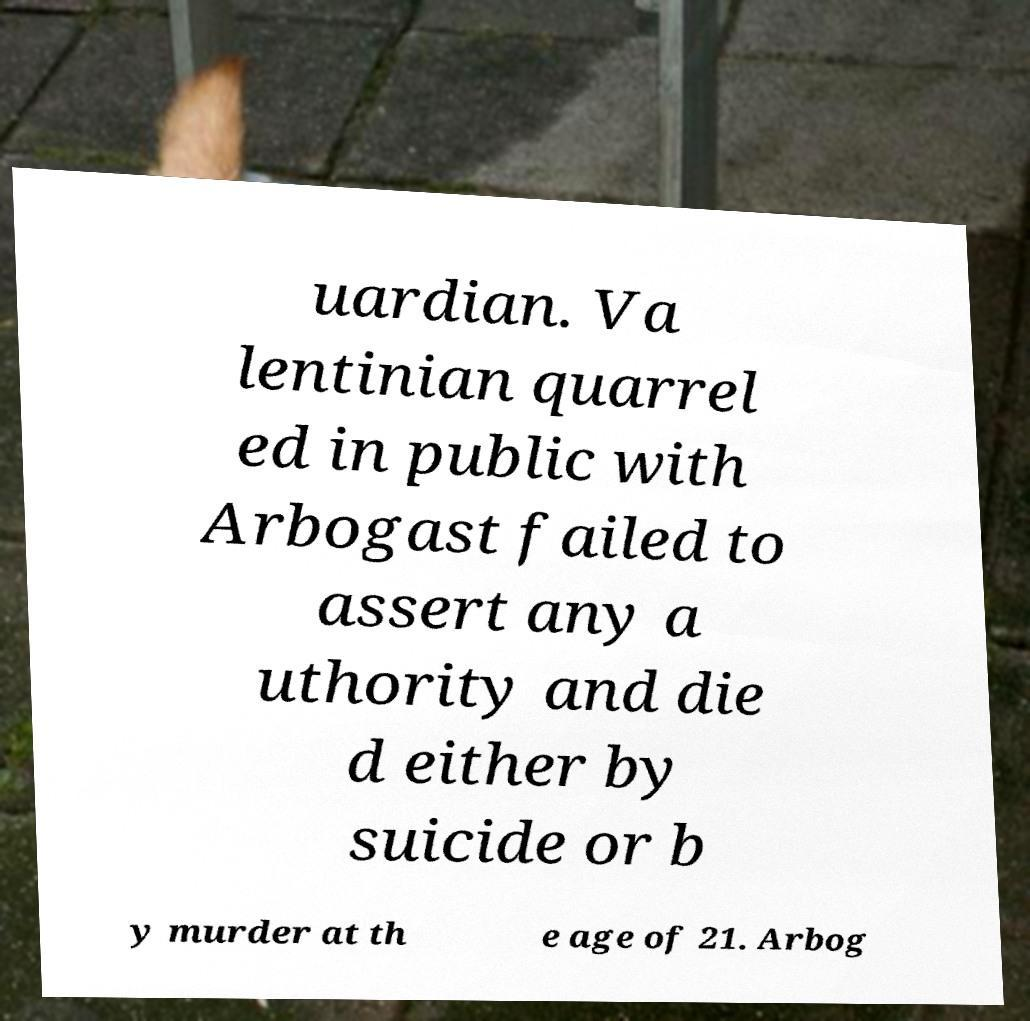Can you read and provide the text displayed in the image?This photo seems to have some interesting text. Can you extract and type it out for me? uardian. Va lentinian quarrel ed in public with Arbogast failed to assert any a uthority and die d either by suicide or b y murder at th e age of 21. Arbog 